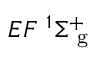<formula> <loc_0><loc_0><loc_500><loc_500>{ E F } ^ { 1 } { \Sigma } _ { g } ^ { + }</formula> 